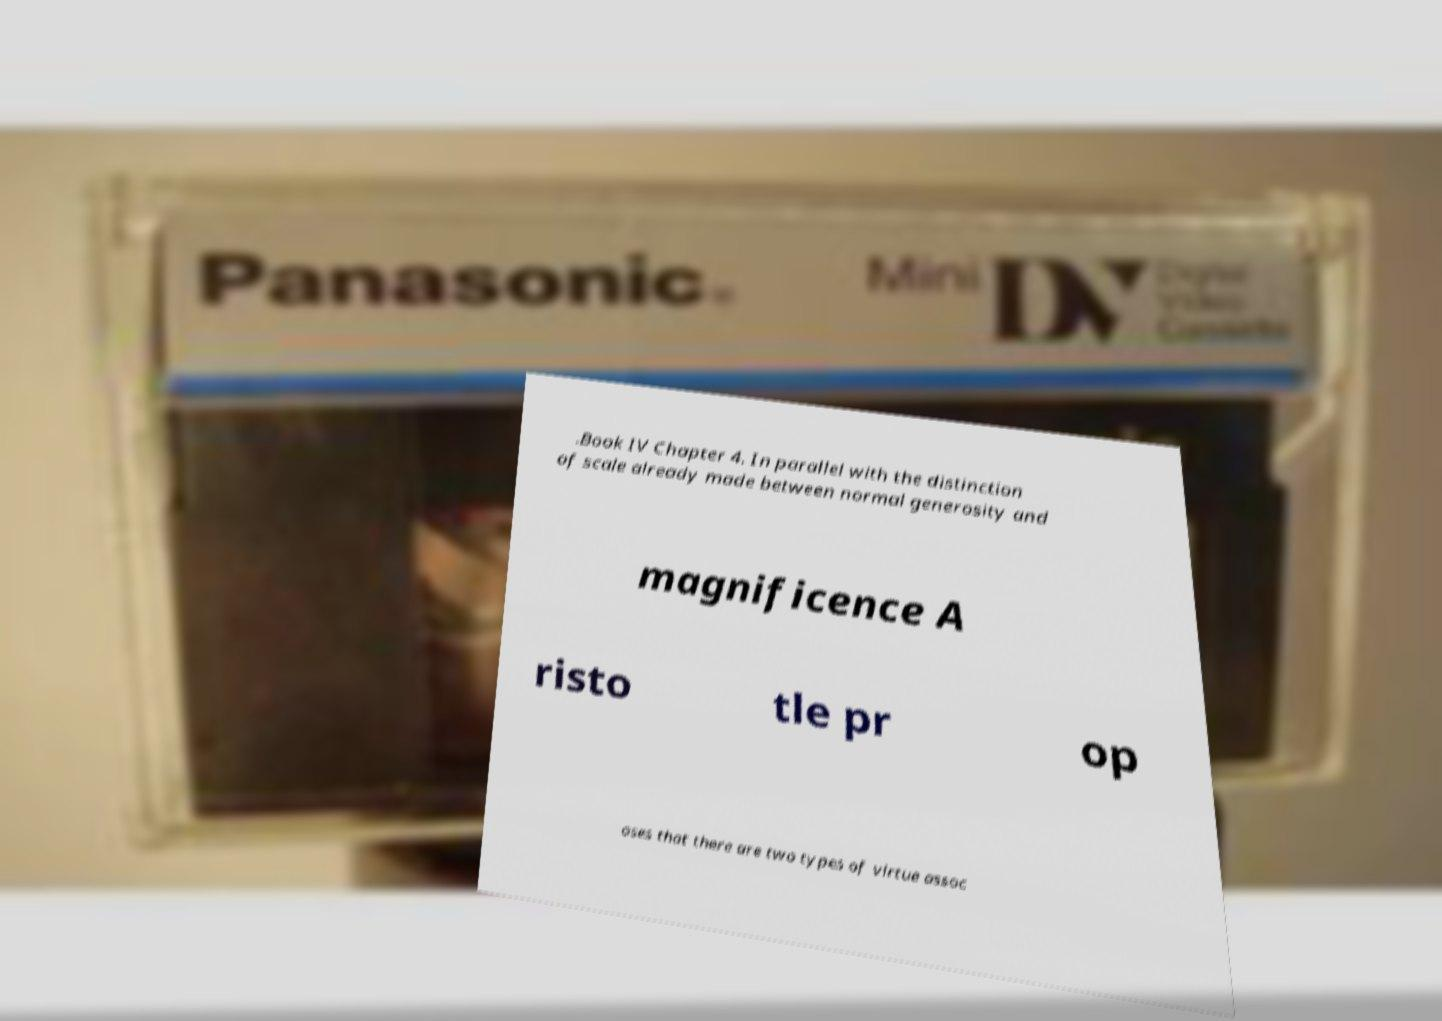What messages or text are displayed in this image? I need them in a readable, typed format. .Book IV Chapter 4. In parallel with the distinction of scale already made between normal generosity and magnificence A risto tle pr op oses that there are two types of virtue assoc 